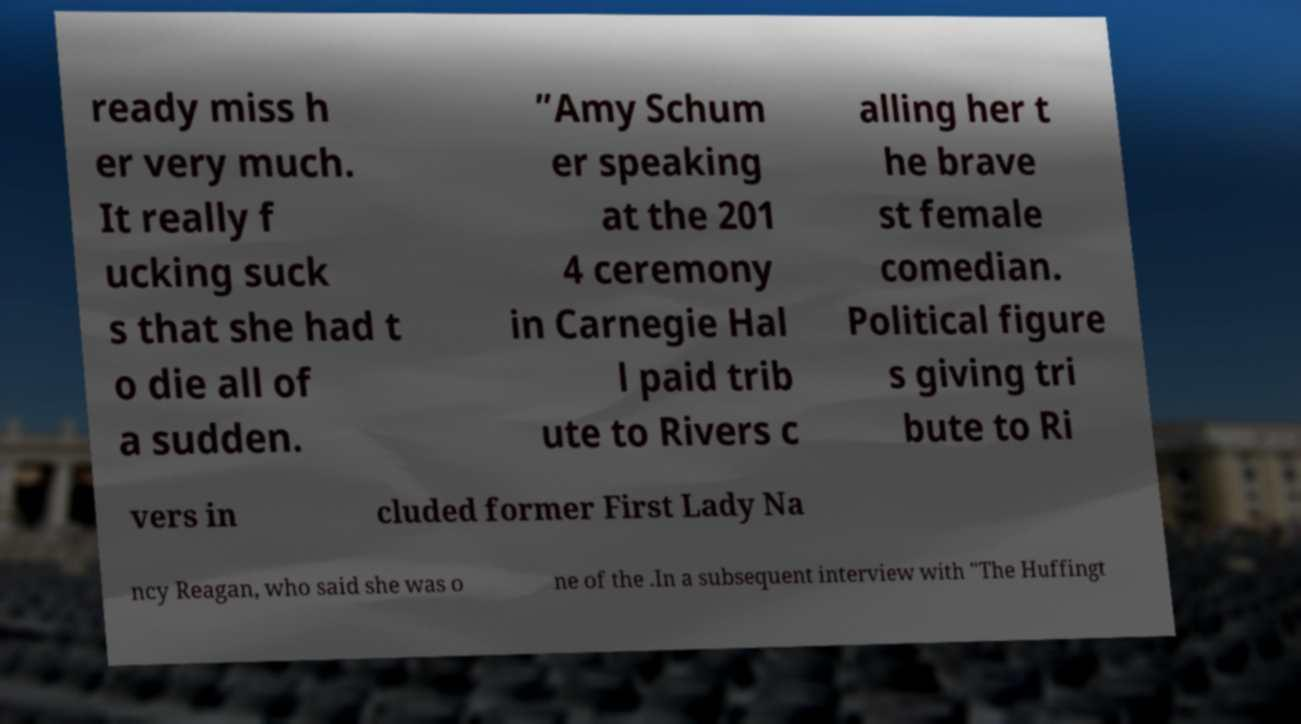I need the written content from this picture converted into text. Can you do that? ready miss h er very much. It really f ucking suck s that she had t o die all of a sudden. ”Amy Schum er speaking at the 201 4 ceremony in Carnegie Hal l paid trib ute to Rivers c alling her t he brave st female comedian. Political figure s giving tri bute to Ri vers in cluded former First Lady Na ncy Reagan, who said she was o ne of the .In a subsequent interview with "The Huffingt 